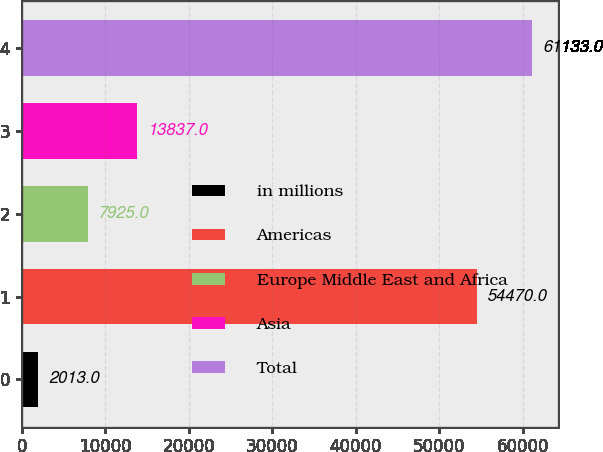Convert chart to OTSL. <chart><loc_0><loc_0><loc_500><loc_500><bar_chart><fcel>in millions<fcel>Americas<fcel>Europe Middle East and Africa<fcel>Asia<fcel>Total<nl><fcel>2013<fcel>54470<fcel>7925<fcel>13837<fcel>61133<nl></chart> 